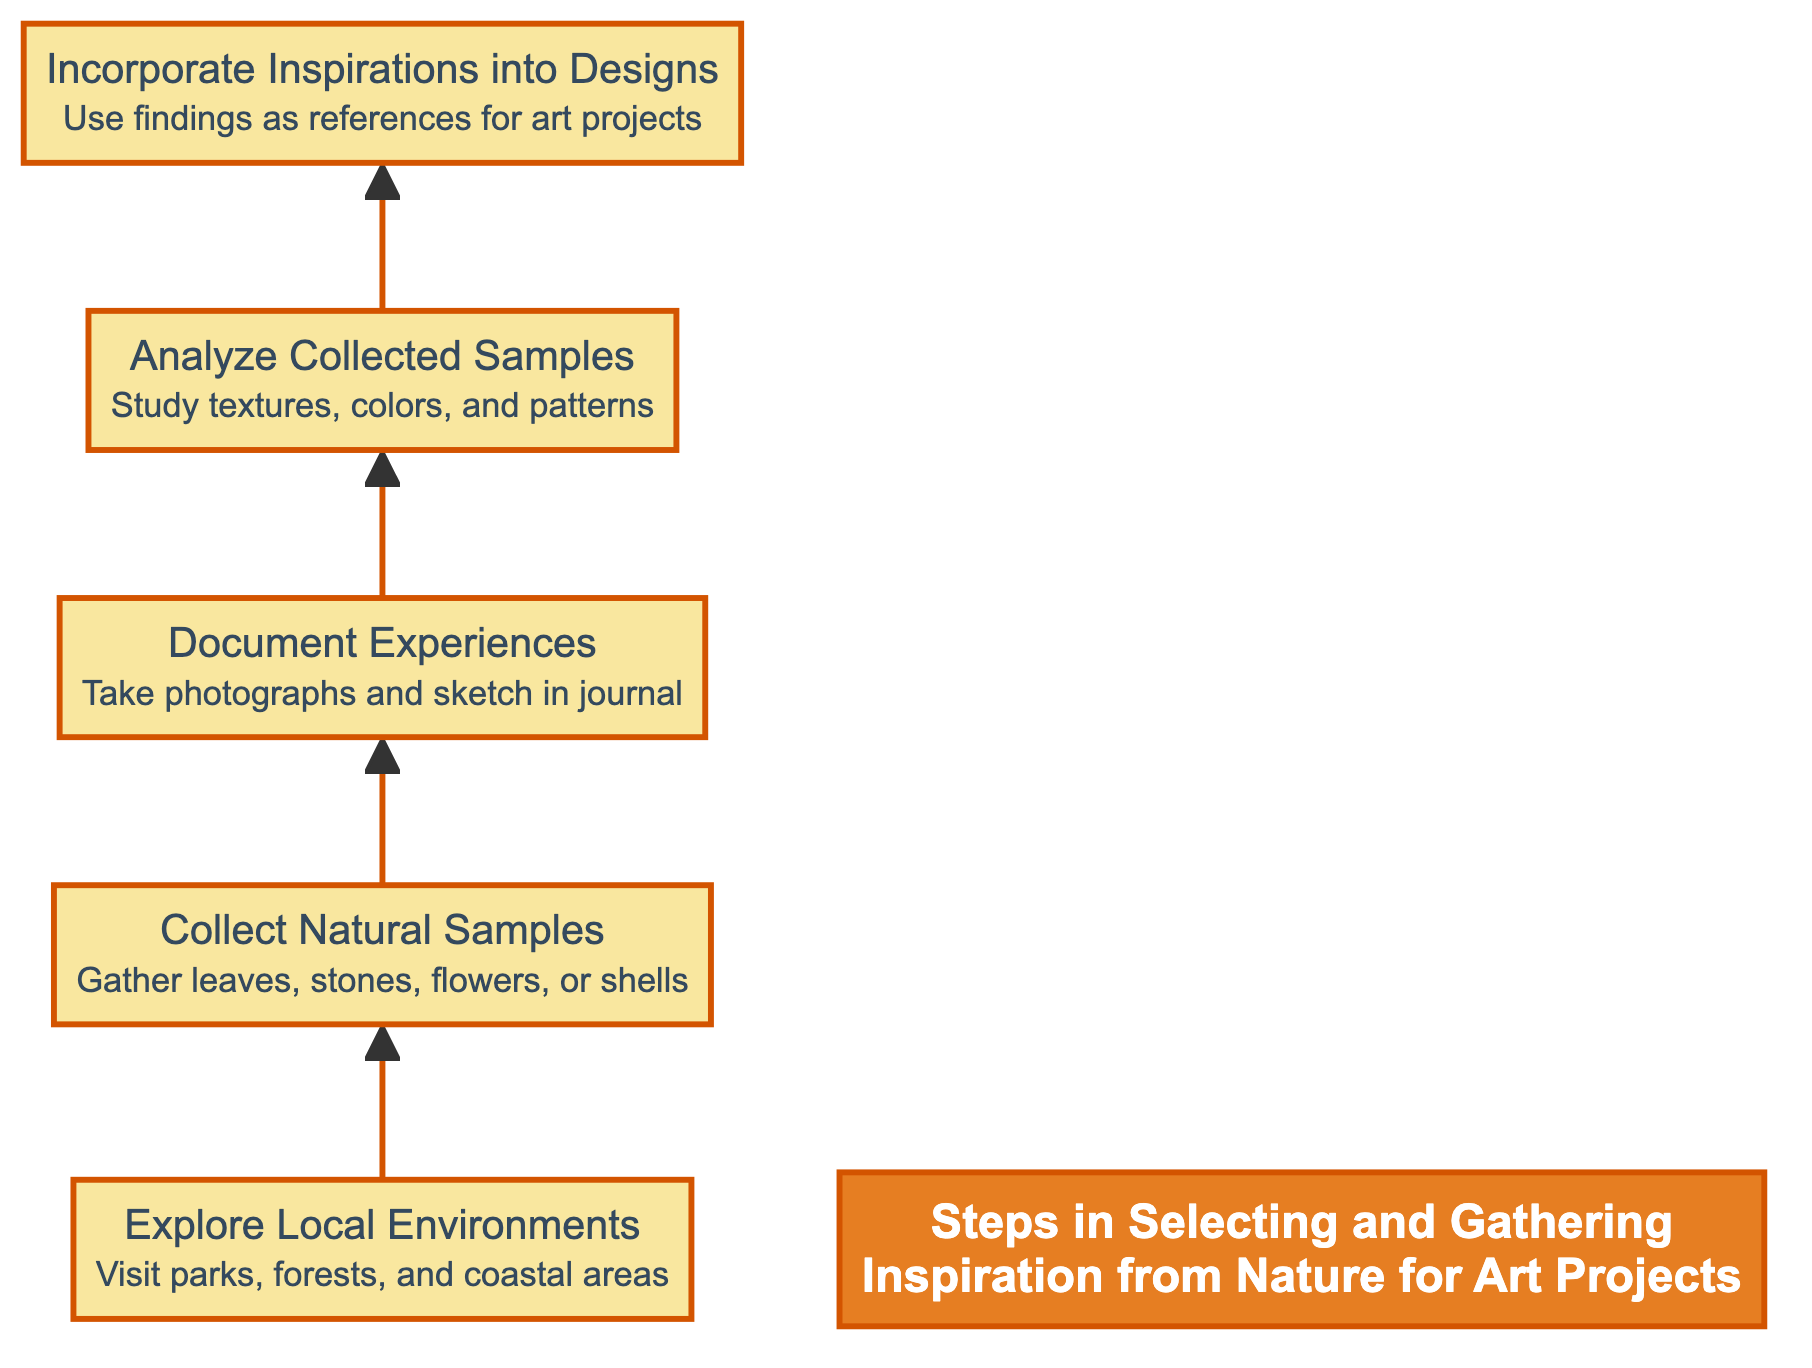What is the first step in the diagram? The diagram lists "Explore Local Environments" as the first step, indicating it's the starting point for gathering inspiration from nature.
Answer: Explore Local Environments How many steps are there in total in the diagram? By counting the individual steps listed in the diagram, we find there are five distinct steps outlined in the process.
Answer: 5 What comes after "Collect Natural Samples"? The sequential relationship in the diagram shows that "Document Experiences" follows after "Collect Natural Samples," representing the next action in the flow.
Answer: Document Experiences What is the last step listed in the diagram? The end of the flow chart indicates that "Incorporate Inspirations into Designs" is the final step, representing the culmination of the process of gathering inspiration.
Answer: Incorporate Inspirations into Designs Which step involves studying textures and patterns? The diagram clearly states that "Analyze Collected Samples" is focused specifically on studying textures, colors, and patterns within the collected natural samples.
Answer: Analyze Collected Samples If you start with "Explore Local Environments," what is the fourth step? Following the flow from "Explore Local Environments" to "Collect Natural Samples," then to "Document Experiences," and then to "Analyze Collected Samples," the fourth step is reached.
Answer: Analyze Collected Samples What action is recommended before "Incorporate Inspirations into Designs"? The diagram outlines that before moving on to "Incorporate Inspirations into Designs," it is essential to go through "Analyze Collected Samples," which is the preceding action.
Answer: Analyze Collected Samples What type of natural items are suggested to be collected? The diagram specifies that individuals should gather leaves, stones, flowers, or shells that catch their attention during the "Collect Natural Samples" step.
Answer: leaves, stones, flowers, shells What does the 'title' of the diagram describe? The title of the diagram, "Steps in Selecting and Gathering Inspiration from Nature for Art Projects," summarizes the overall theme and purpose of the flowchart.
Answer: Steps in Selecting and Gathering Inspiration from Nature for Art Projects 